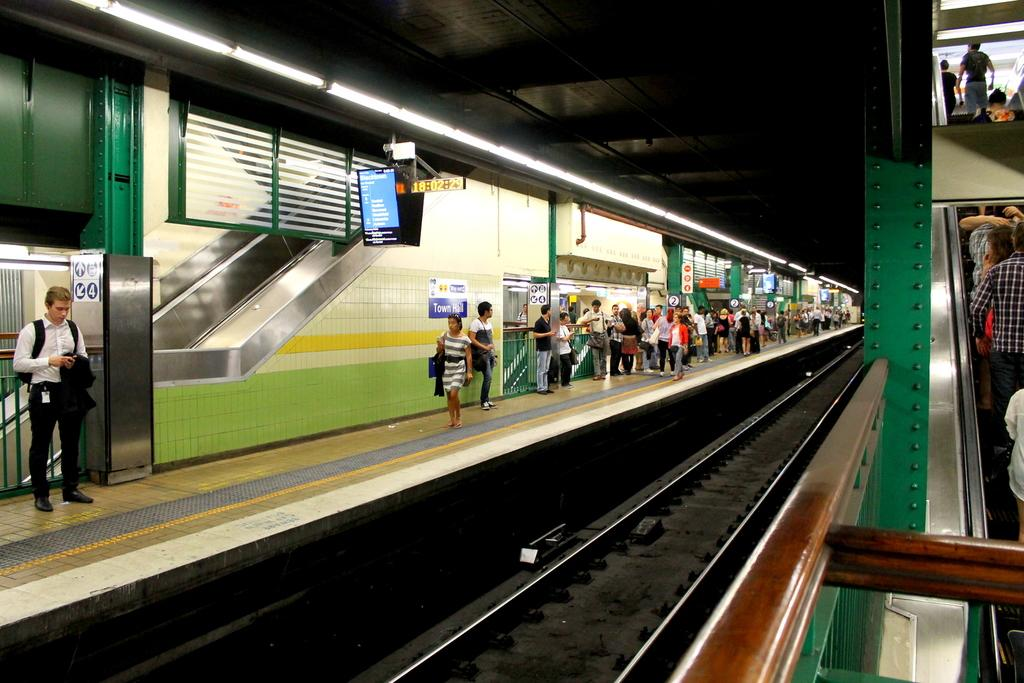What type of transportation infrastructure is present in the image? There is a railway track in the image. What is located near the railway track? There is a platform in the image. Who can be seen near the platform? There are people standing on the platform. What feature is present to help passengers move between different levels? There is an escalator in the image. What can be seen providing illumination on the platform? There are lights visible above the platform. What type of toys are the people playing with on the platform? There are no toys visible in the image; people are standing on the platform. What vacation destination can be seen in the background of the image? There is no vacation destination present in the image; it features a railway platform and people standing on it. 